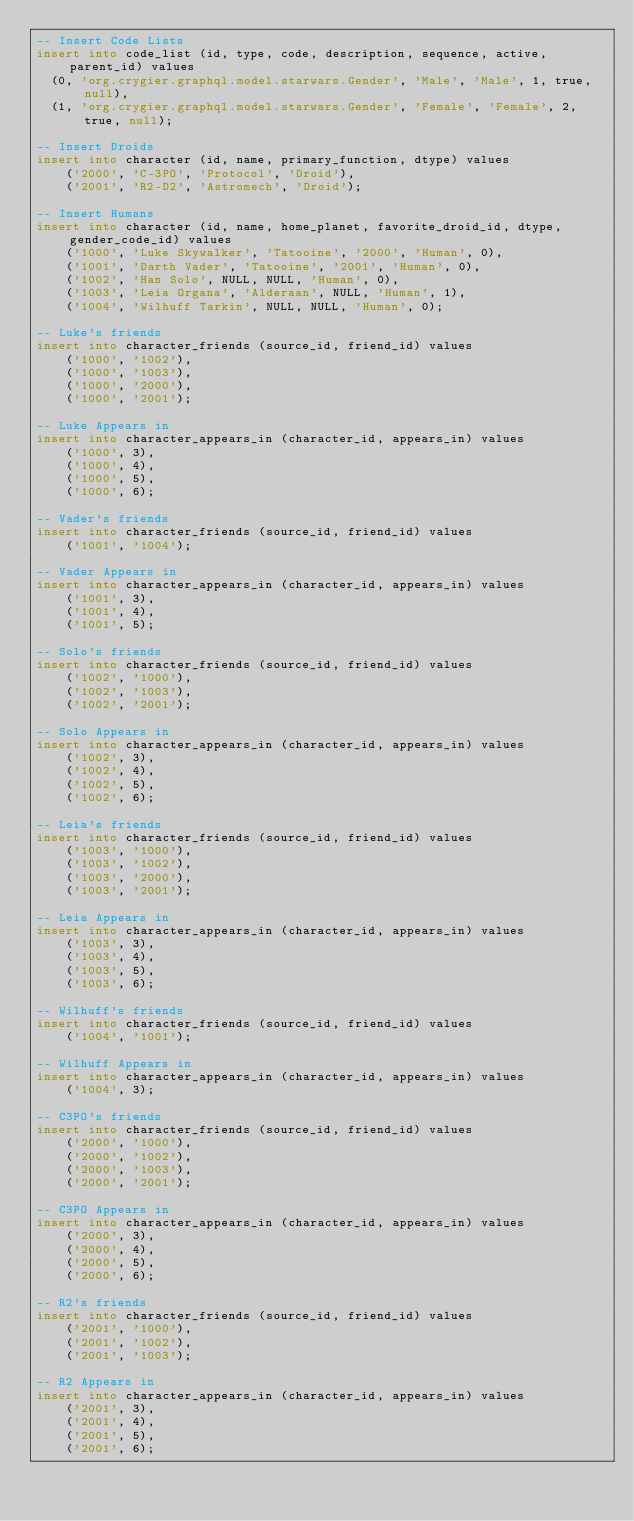Convert code to text. <code><loc_0><loc_0><loc_500><loc_500><_SQL_>-- Insert Code Lists
insert into code_list (id, type, code, description, sequence, active, parent_id) values 
  (0, 'org.crygier.graphql.model.starwars.Gender', 'Male', 'Male', 1, true, null),
  (1, 'org.crygier.graphql.model.starwars.Gender', 'Female', 'Female', 2, true, null);

-- Insert Droids
insert into character (id, name, primary_function, dtype) values
    ('2000', 'C-3PO', 'Protocol', 'Droid'),
    ('2001', 'R2-D2', 'Astromech', 'Droid');

-- Insert Humans
insert into character (id, name, home_planet, favorite_droid_id, dtype, gender_code_id) values
    ('1000', 'Luke Skywalker', 'Tatooine', '2000', 'Human', 0),
    ('1001', 'Darth Vader', 'Tatooine', '2001', 'Human', 0),
    ('1002', 'Han Solo', NULL, NULL, 'Human', 0),
    ('1003', 'Leia Organa', 'Alderaan', NULL, 'Human', 1),
    ('1004', 'Wilhuff Tarkin', NULL, NULL, 'Human', 0);

-- Luke's friends
insert into character_friends (source_id, friend_id) values
    ('1000', '1002'),
    ('1000', '1003'),
    ('1000', '2000'),
    ('1000', '2001');

-- Luke Appears in
insert into character_appears_in (character_id, appears_in) values
    ('1000', 3),
    ('1000', 4),
    ('1000', 5),
    ('1000', 6);

-- Vader's friends
insert into character_friends (source_id, friend_id) values
    ('1001', '1004');

-- Vader Appears in
insert into character_appears_in (character_id, appears_in) values
    ('1001', 3),
    ('1001', 4),
    ('1001', 5);

-- Solo's friends
insert into character_friends (source_id, friend_id) values
    ('1002', '1000'),
    ('1002', '1003'),
    ('1002', '2001');

-- Solo Appears in
insert into character_appears_in (character_id, appears_in) values
    ('1002', 3),
    ('1002', 4),
    ('1002', 5),
    ('1002', 6);

-- Leia's friends
insert into character_friends (source_id, friend_id) values
    ('1003', '1000'),
    ('1003', '1002'),
    ('1003', '2000'),
    ('1003', '2001');

-- Leia Appears in
insert into character_appears_in (character_id, appears_in) values
    ('1003', 3),
    ('1003', 4),
    ('1003', 5),
    ('1003', 6);

-- Wilhuff's friends
insert into character_friends (source_id, friend_id) values
    ('1004', '1001');

-- Wilhuff Appears in
insert into character_appears_in (character_id, appears_in) values
    ('1004', 3);

-- C3PO's friends
insert into character_friends (source_id, friend_id) values
    ('2000', '1000'),
    ('2000', '1002'),
    ('2000', '1003'),
    ('2000', '2001');

-- C3PO Appears in
insert into character_appears_in (character_id, appears_in) values
    ('2000', 3),
    ('2000', 4),
    ('2000', 5),
    ('2000', 6);

-- R2's friends
insert into character_friends (source_id, friend_id) values
    ('2001', '1000'),
    ('2001', '1002'),
    ('2001', '1003');

-- R2 Appears in
insert into character_appears_in (character_id, appears_in) values
    ('2001', 3),
    ('2001', 4),
    ('2001', 5),
    ('2001', 6);

</code> 